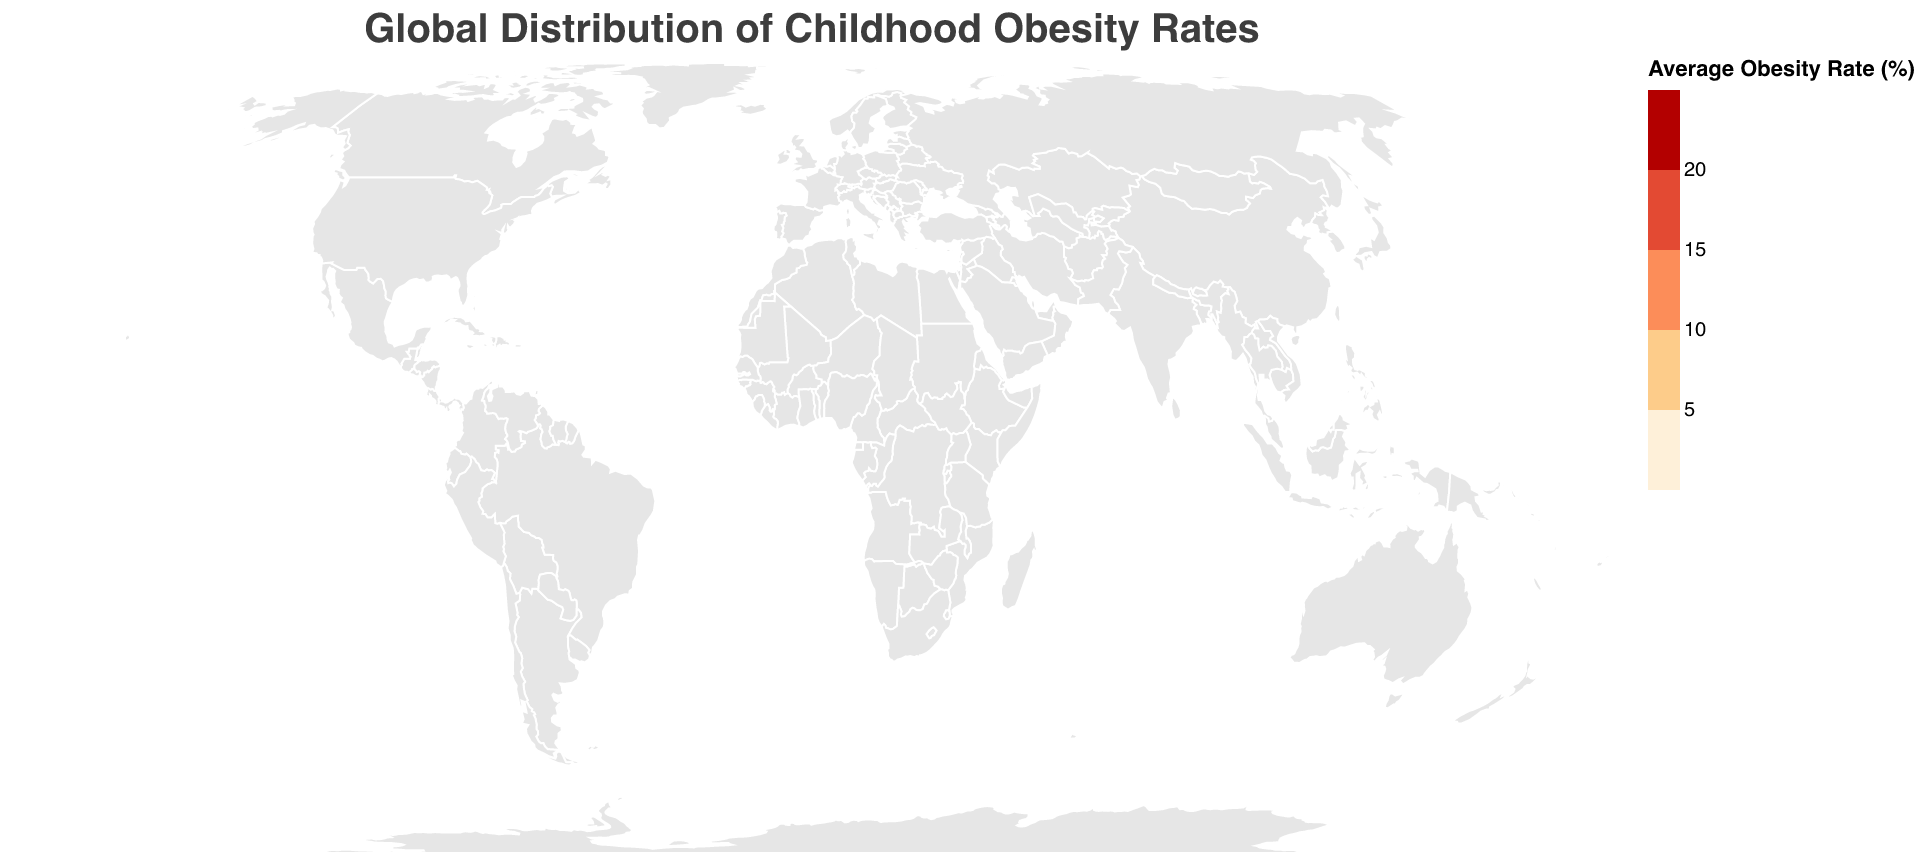What is the title of the figure? The title is usually located at the top of the figure. In this case, the title says "Global Distribution of Childhood Obesity Rates" in larger font size.
Answer: Global Distribution of Childhood Obesity Rates Which country shows the highest average childhood obesity rate? By referring to the color shades and tooltip information associated with each country, the darkest shaded region with the highest average obesity rate is evident. The United States has the darkest color, indicating the highest rate.
Answer: United States What is the average childhood obesity rate in China? Refer to the tooltip or the color coding associated with China. The average obesity rate can be gleaned from there. It corresponds to a lighter shade indicating a lower rate. The tooltip shows an average rate of around 7.6%.
Answer: 7.6% How does the average obesity rate in Australia compare to India? From the color shades and by referring to the tooltips for both countries, Australia has a middle-range shade, while India has a very light shade, which means Australia has a higher rate compared to India. Australia's average is greater than India's.
Answer: Higher Which age group in the United States has the highest obesity rate? Look into each data point for the United States and compare the obesity rates for both age groups (5-9 and 10-14). The 10-14 age group has higher obesity rates for both genders. The combined rate for 10-14 is the highest.
Answer: 10-14 Which gender in Brazil has a higher obesity rate for the 5-9 age group? Check the data points for Brazil under the 5-9 age group and compare the rates for males and females. Males have a rate of 15.3%, while females have 14.1%.
Answer: Male Calculate the average childhood obesity rate globally for the age group 10-14. Calculate the average from the given data for the 10-14 age group. Sum the obesity rates for this age group and divide by the number of data points. ((22.5 + 20.1 + 16.8 + 15.6 + 8.9 + 7.8 + 17.6 + 16.2 + 4.5 + 3.9 + 18.9 + 17.3) / 12).
Answer: 14.6% Which continent has the lowest childhood obesity rate? By scanning the different countries and using the respective colors, and knowing the continents they belong to, India from Asia stands out with the lightest shade. Therefore, Asia has the lowest rate among the continents presented.
Answer: Asia Identify which country has the closest obesity rate between males and females for the 10-14 age group. Compare the obesity rates between males and females for each country in the 10-14 age group. China has the closest rates (Male: 8.9%, Female: 7.8%).
Answer: China 